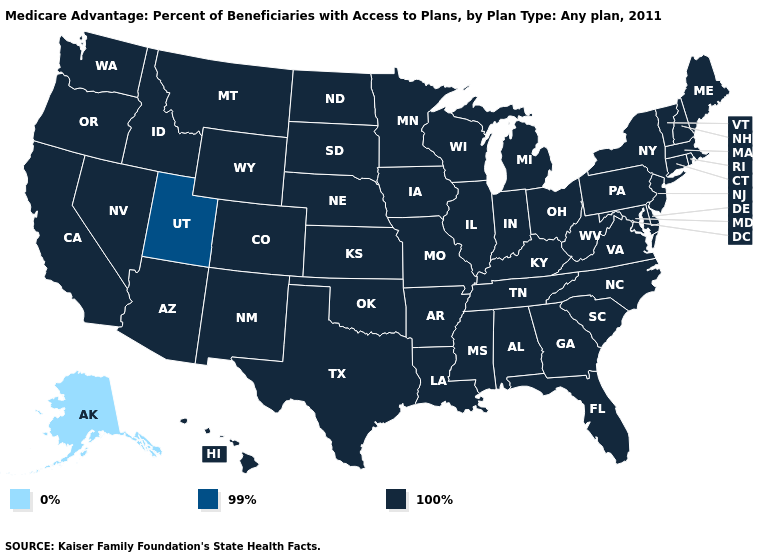What is the value of California?
Quick response, please. 100%. What is the lowest value in the USA?
Short answer required. 0%. Which states have the highest value in the USA?
Concise answer only. Alabama, Arkansas, Arizona, California, Colorado, Connecticut, Delaware, Florida, Georgia, Hawaii, Iowa, Idaho, Illinois, Indiana, Kansas, Kentucky, Louisiana, Massachusetts, Maryland, Maine, Michigan, Minnesota, Missouri, Mississippi, Montana, North Carolina, North Dakota, Nebraska, New Hampshire, New Jersey, New Mexico, Nevada, New York, Ohio, Oklahoma, Oregon, Pennsylvania, Rhode Island, South Carolina, South Dakota, Tennessee, Texas, Virginia, Vermont, Washington, Wisconsin, West Virginia, Wyoming. What is the value of Montana?
Quick response, please. 100%. Name the states that have a value in the range 99%?
Quick response, please. Utah. Name the states that have a value in the range 99%?
Short answer required. Utah. Name the states that have a value in the range 0%?
Keep it brief. Alaska. What is the highest value in the Northeast ?
Concise answer only. 100%. What is the highest value in the Northeast ?
Short answer required. 100%. Name the states that have a value in the range 0%?
Concise answer only. Alaska. Does Indiana have a lower value than Kansas?
Keep it brief. No. Which states hav the highest value in the Northeast?
Concise answer only. Connecticut, Massachusetts, Maine, New Hampshire, New Jersey, New York, Pennsylvania, Rhode Island, Vermont. Among the states that border Wyoming , does Utah have the highest value?
Short answer required. No. How many symbols are there in the legend?
Be succinct. 3. Which states hav the highest value in the MidWest?
Give a very brief answer. Iowa, Illinois, Indiana, Kansas, Michigan, Minnesota, Missouri, North Dakota, Nebraska, Ohio, South Dakota, Wisconsin. 